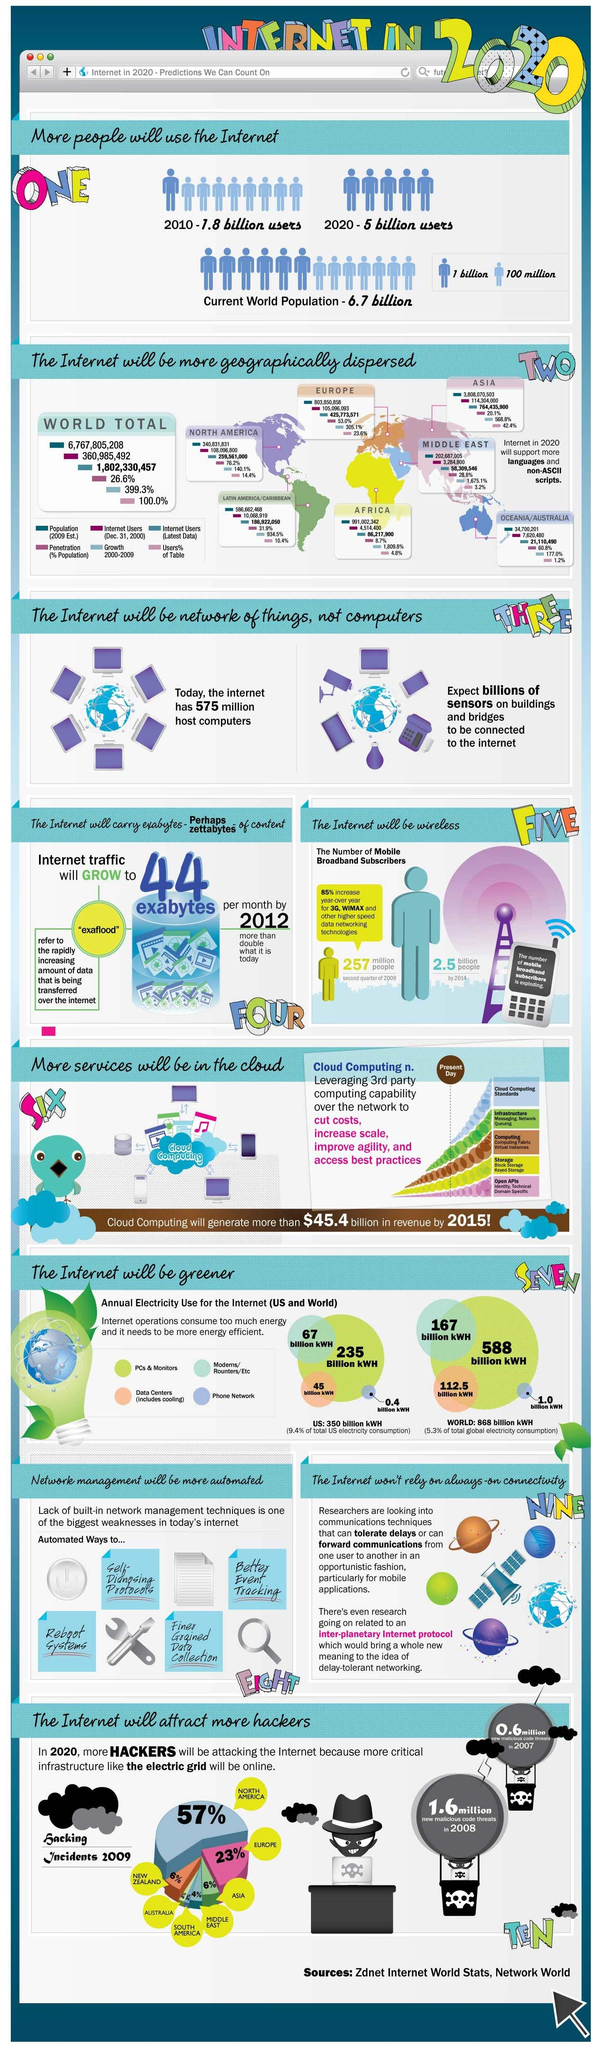Give some essential details in this illustration. The number of new malicious code threats increased by approximately 1.0 million from 2007 to 2008. North America has the highest number of hacking incidents. The number of internet users has increased by 3.2 billion from 2010 to 2020. 